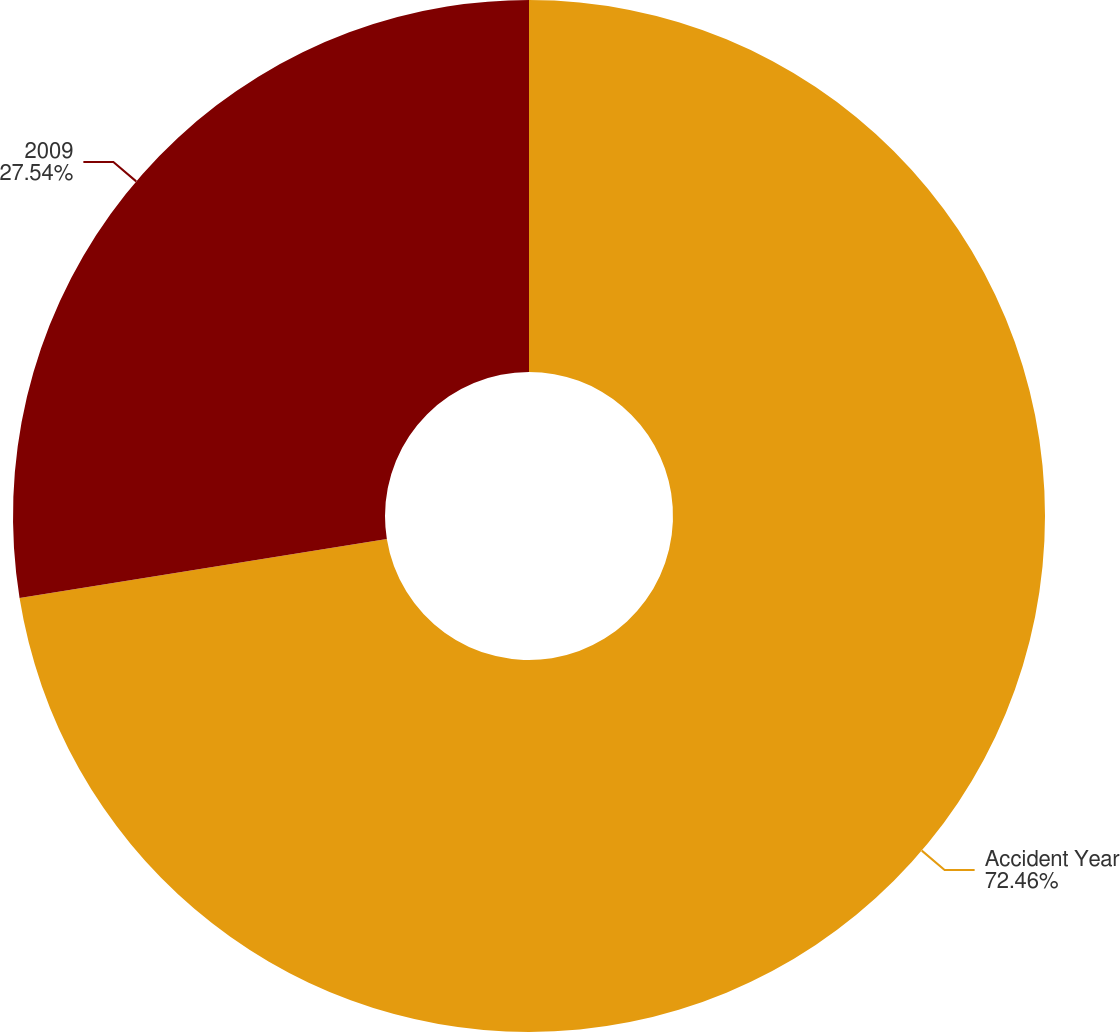Convert chart to OTSL. <chart><loc_0><loc_0><loc_500><loc_500><pie_chart><fcel>Accident Year<fcel>2009<nl><fcel>72.46%<fcel>27.54%<nl></chart> 